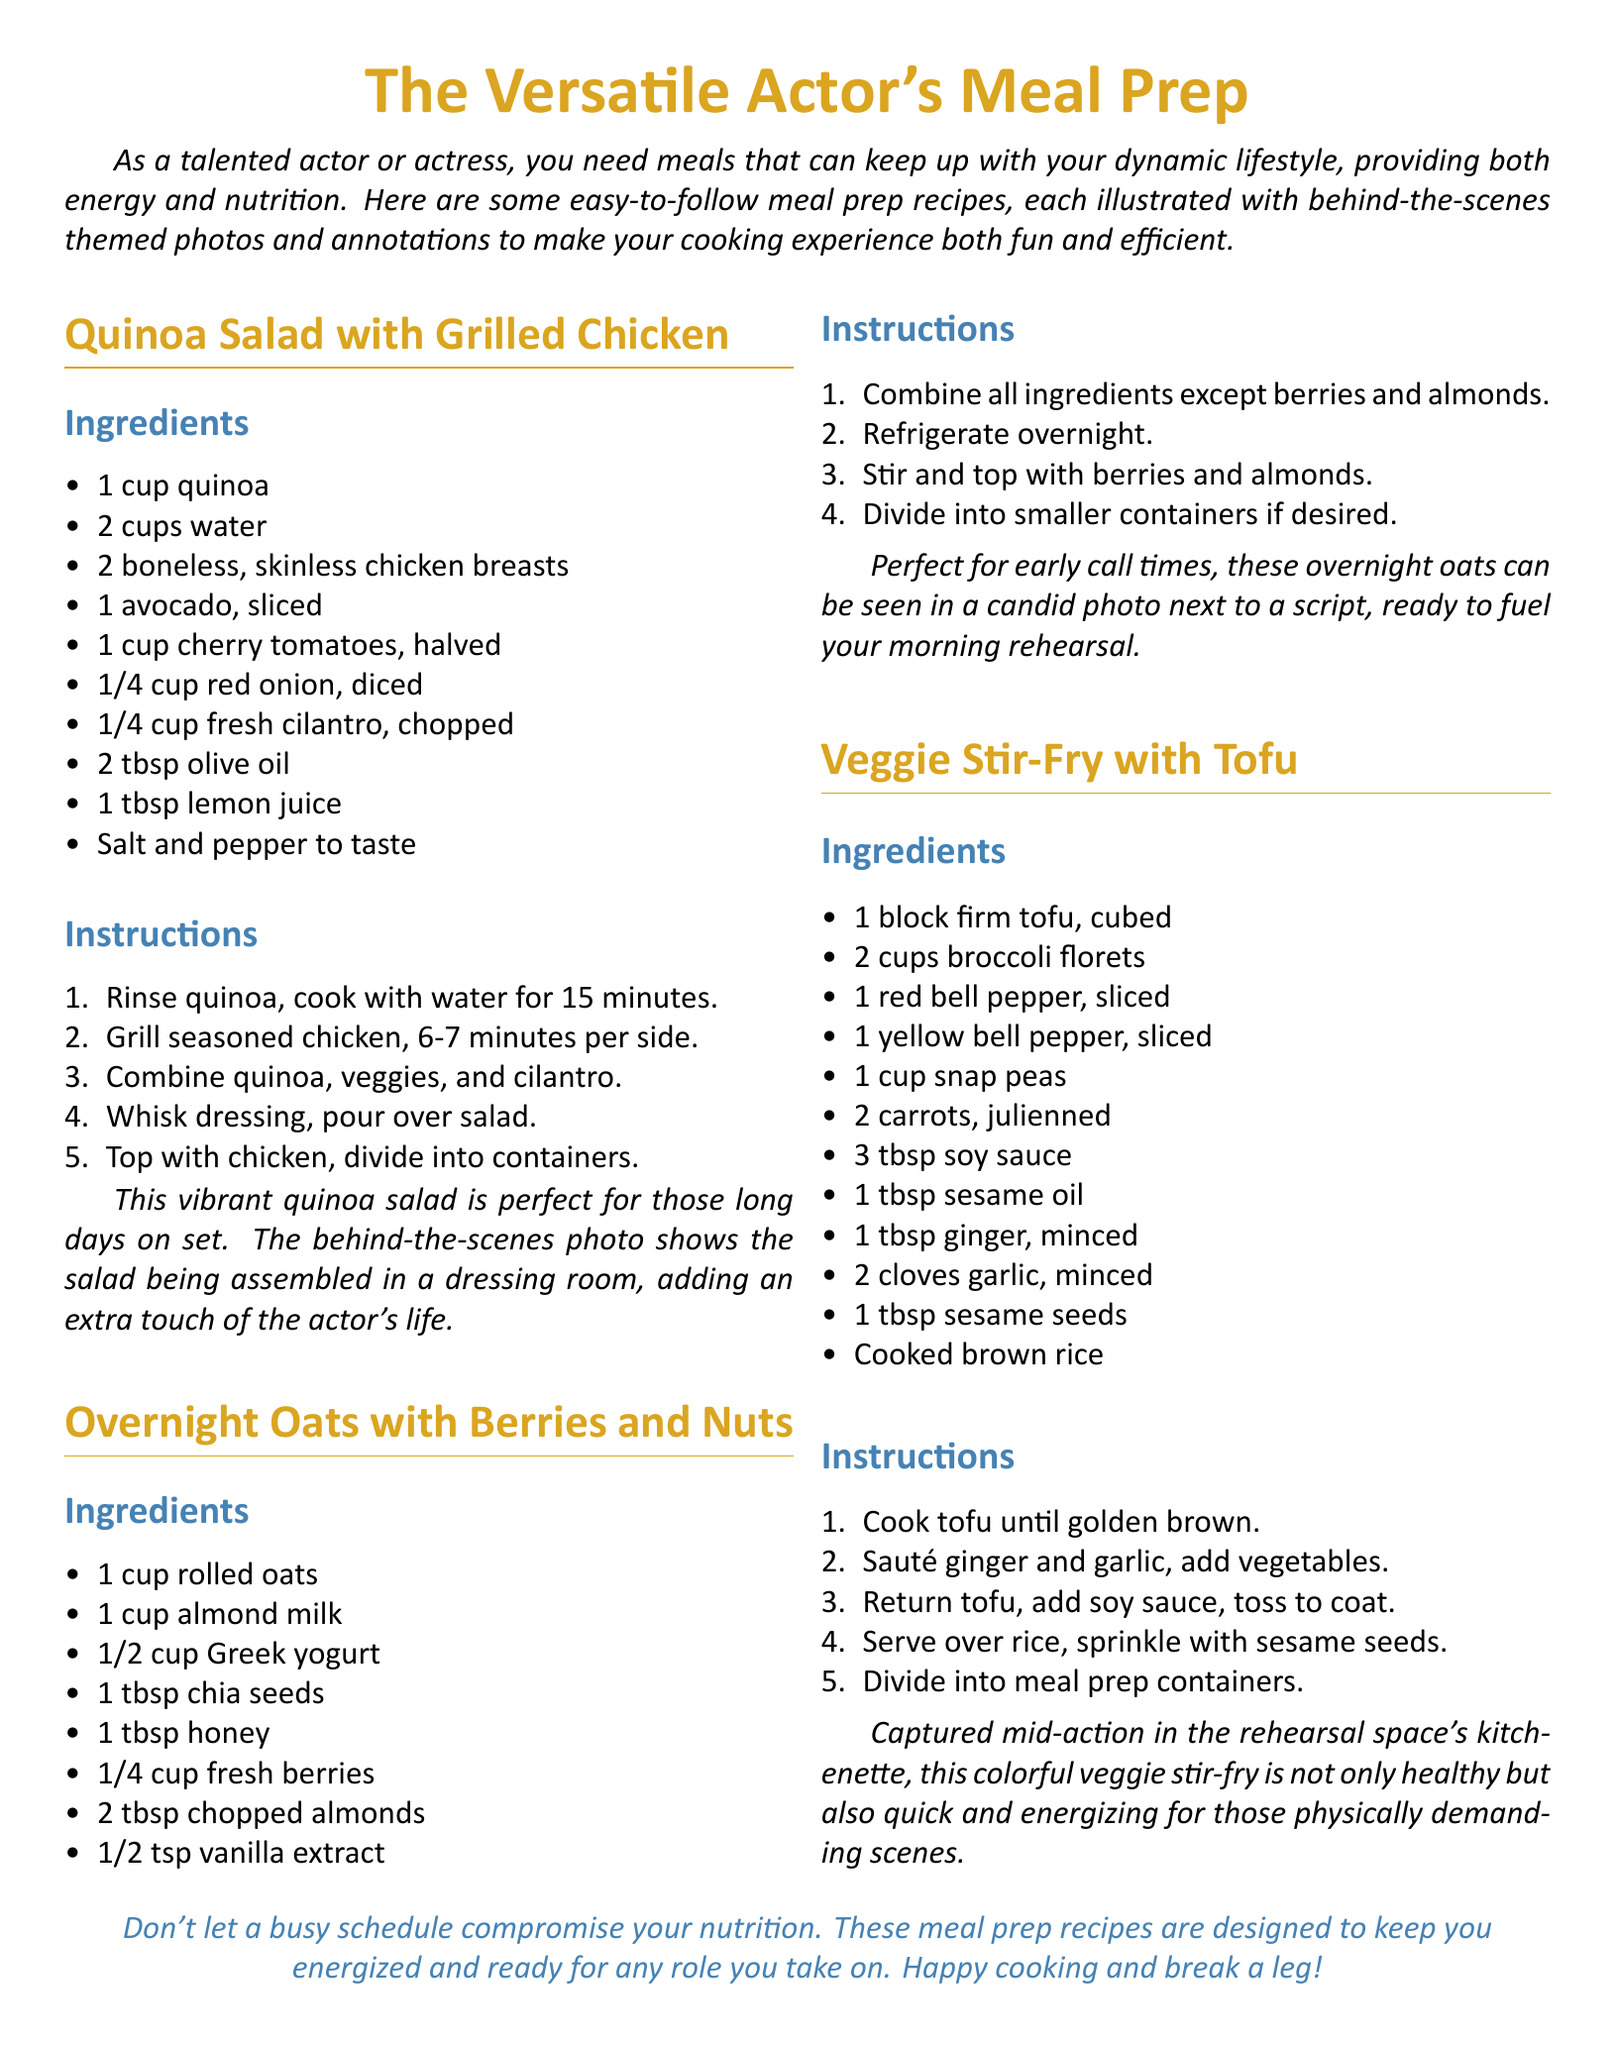What are the main ingredients in the Quinoa Salad? The main ingredients are listed under the Quinoa Salad section, which includes quinoa, chicken breasts, avocado, cherry tomatoes, red onion, cilantro, olive oil, lemon juice, salt, and pepper.
Answer: quinoa, chicken breasts, avocado, cherry tomatoes, red onion, cilantro, olive oil, lemon juice, salt, pepper How long do you cook the quinoa? The cooking time for quinoa is specified in the instructions for the Quinoa Salad, which states to cook for 15 minutes.
Answer: 15 minutes What is the purpose of chia seeds in the Overnight Oats recipe? Chia seeds are included in the ingredients list for Overnight Oats, implying they add nutrition and texture to the dish.
Answer: Nutrition and texture How many servings of the Veggie Stir-Fry can be prepared? The recipe does not specify number of servings, but it is implied that you can divide the dish into meal prep containers.
Answer: Multiple servings What is the primary protein source in the Veggie Stir-Fry? The primary protein source in the Veggie Stir-Fry is indicated to be tofu, as it is listed prominently among the ingredients.
Answer: Tofu Why are these meal prep recipes designed for actors? The introduction states these recipes provide energy and nutrition tailored for busy actors, supporting their dynamic lifestyles.
Answer: Energy and nutrition for busy actors What type of milk is used in the Overnight Oats? The ingredient list for the Overnight Oats specifies the use of almond milk.
Answer: Almond milk What color are the headings in the recipe card? The headings are colored gold and blue, as specified by the color definitions in the document.
Answer: Gold and blue 